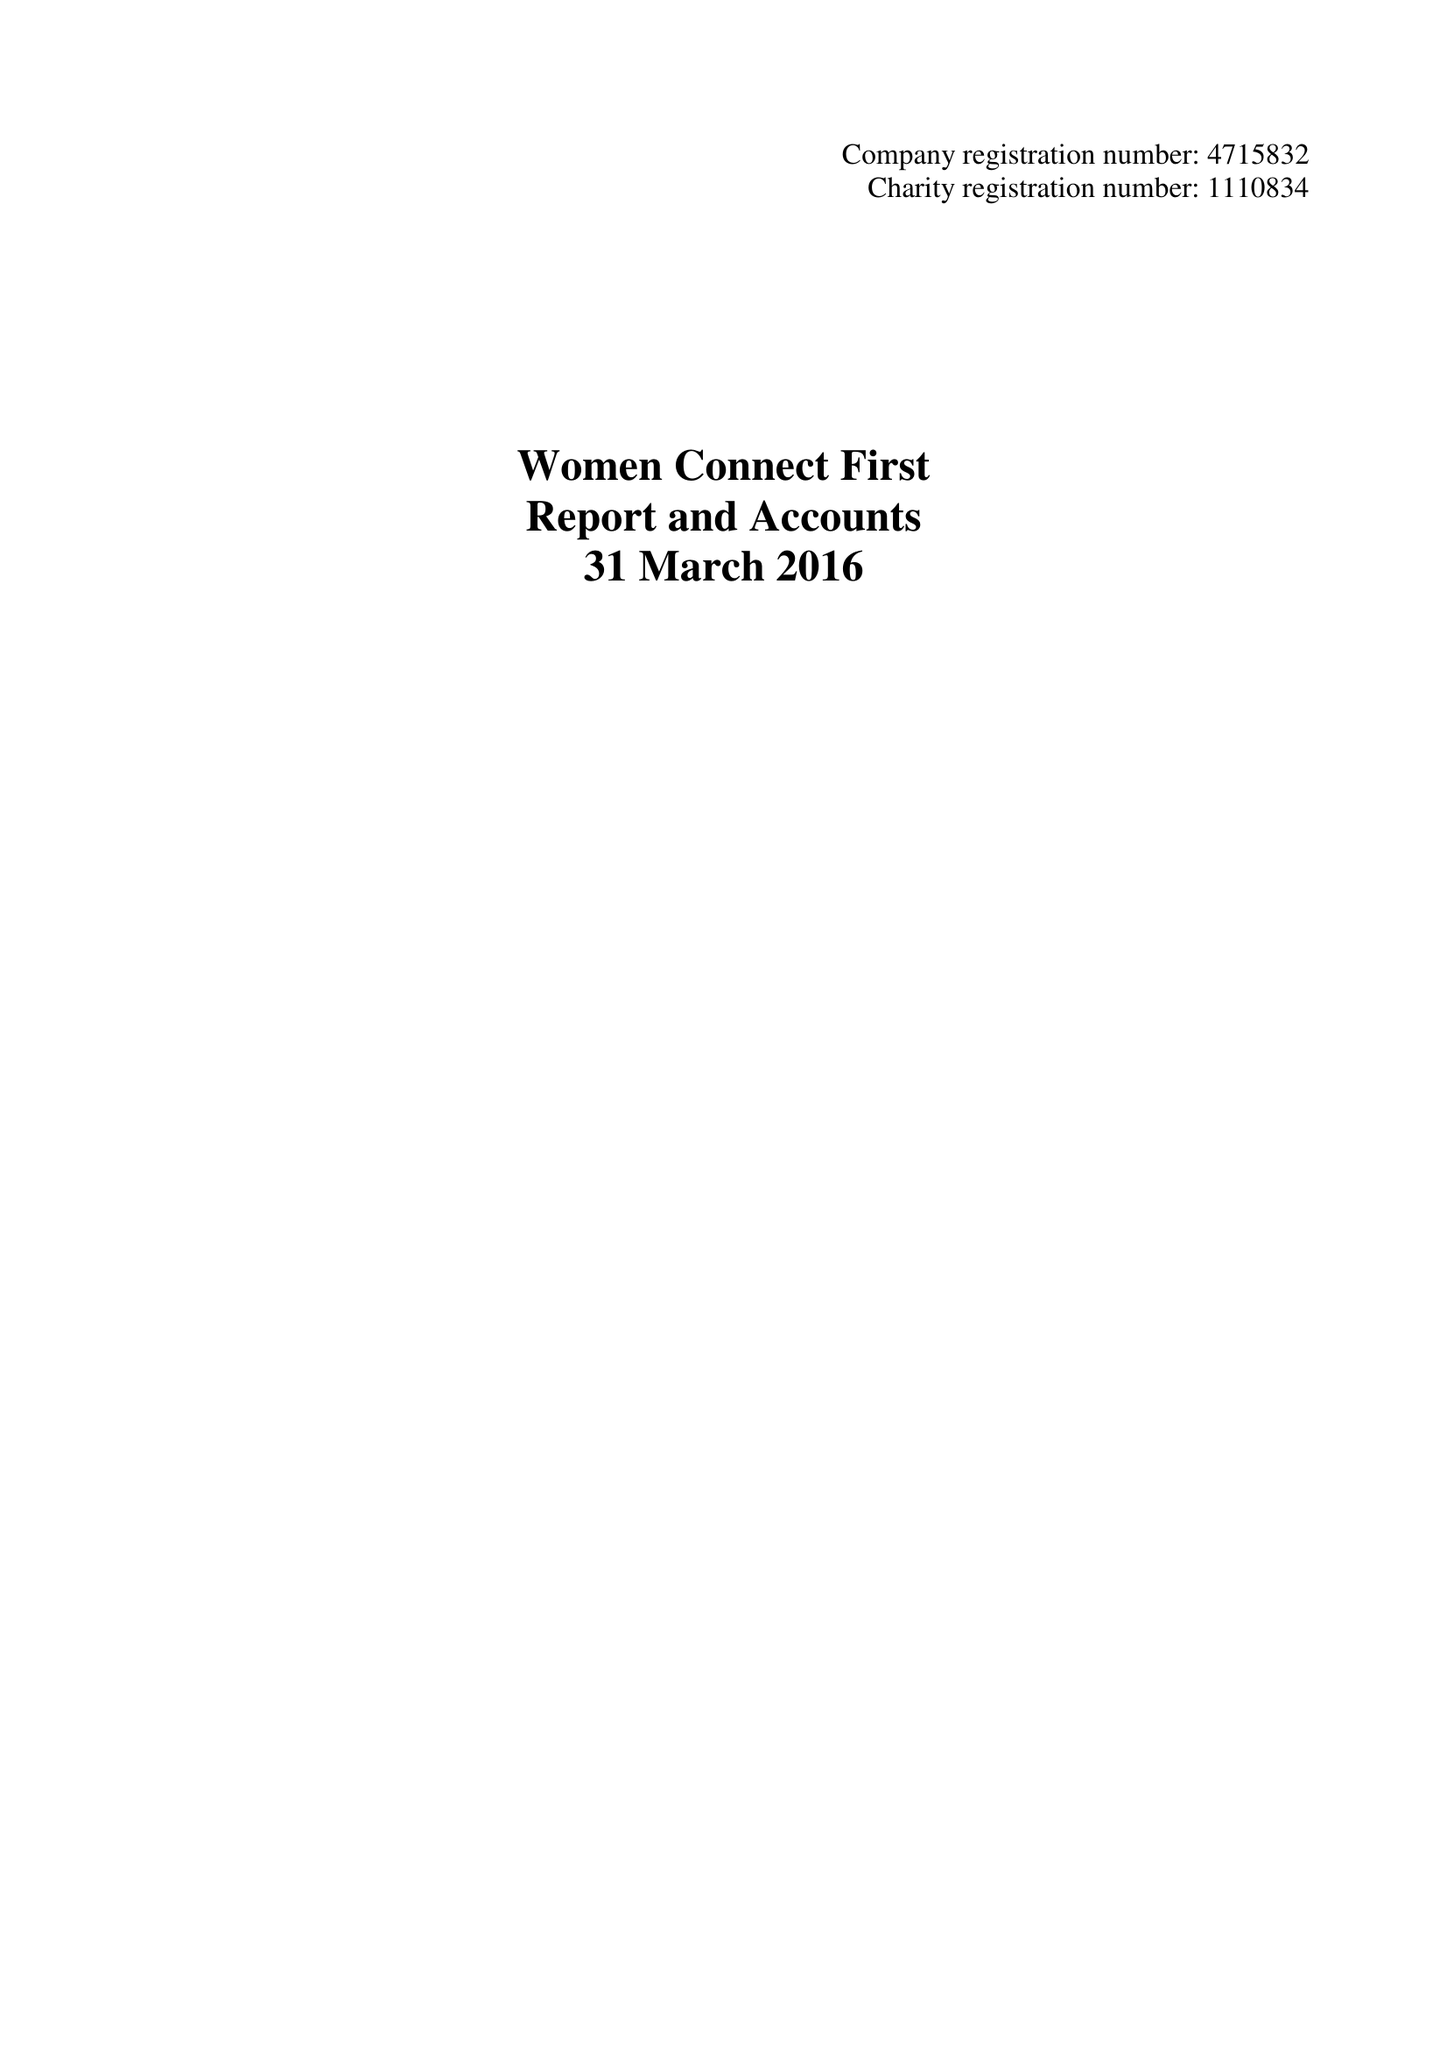What is the value for the spending_annually_in_british_pounds?
Answer the question using a single word or phrase. 357551.00 